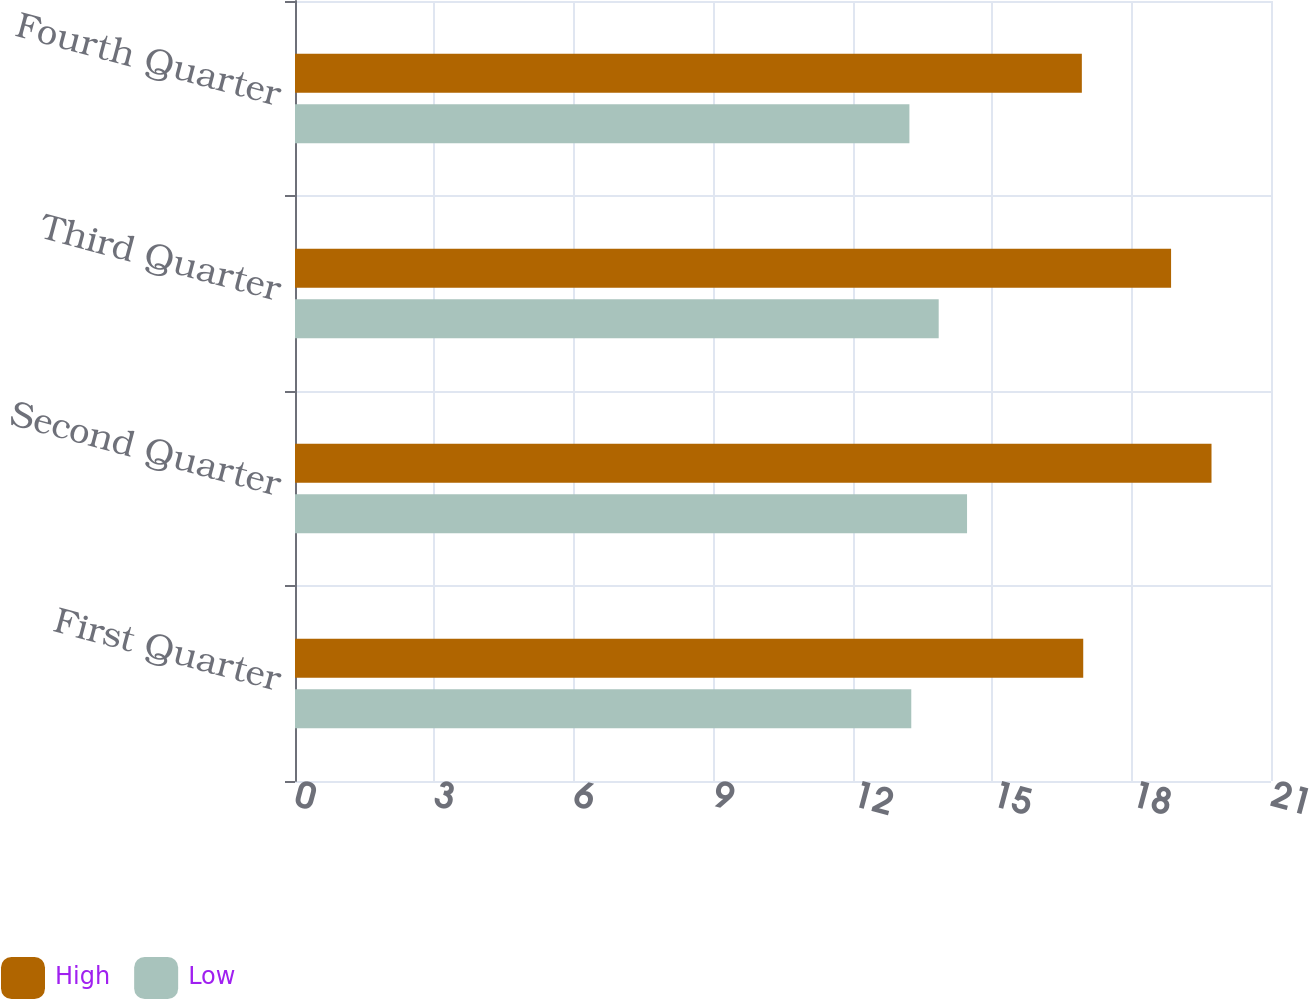<chart> <loc_0><loc_0><loc_500><loc_500><stacked_bar_chart><ecel><fcel>First Quarter<fcel>Second Quarter<fcel>Third Quarter<fcel>Fourth Quarter<nl><fcel>High<fcel>16.96<fcel>19.72<fcel>18.85<fcel>16.93<nl><fcel>Low<fcel>13.26<fcel>14.46<fcel>13.85<fcel>13.22<nl></chart> 